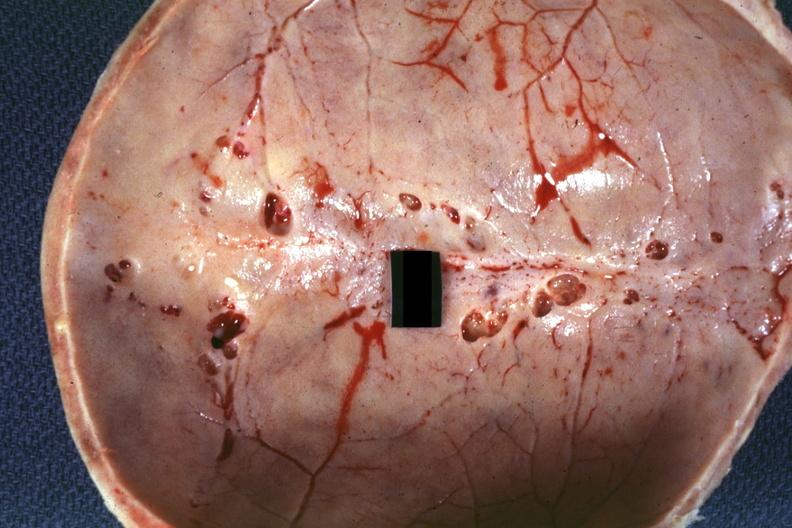what is present?
Answer the question using a single word or phrase. Bone 